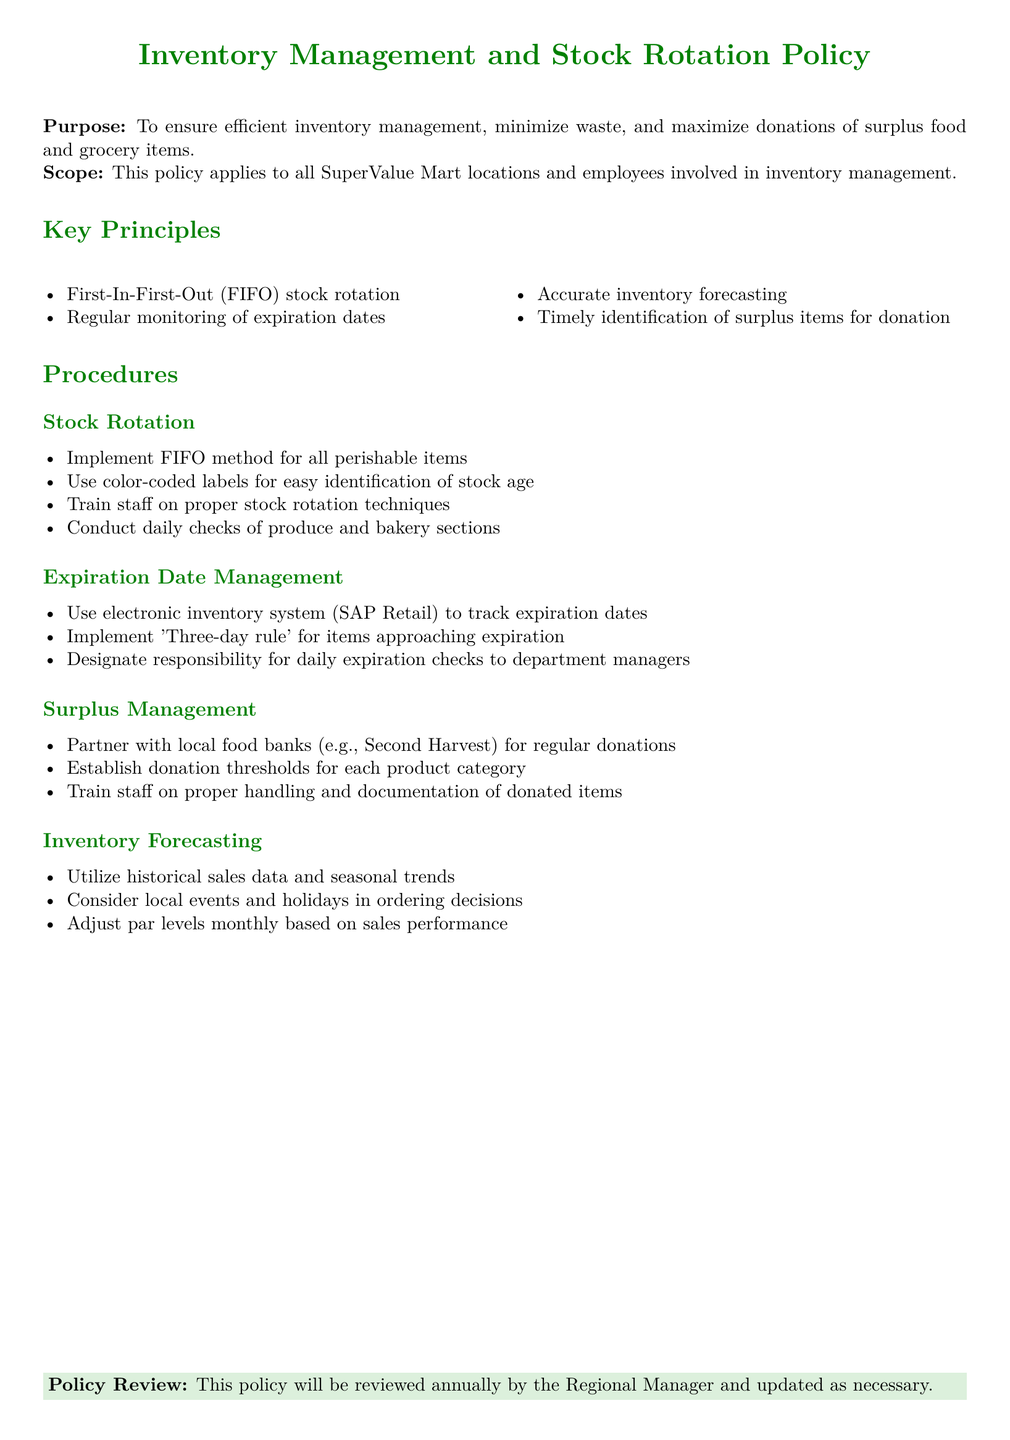What is the purpose of the policy? The purpose of the policy is to ensure efficient inventory management, minimize waste, and maximize donations of surplus food and grocery items.
Answer: To ensure efficient inventory management, minimize waste, and maximize donations of surplus food and grocery items Which method should be implemented for stock rotation? The document specifies the stock rotation method that should be used for perishable items.
Answer: First-In-First-Out (FIFO) What system is used to track expiration dates? The electronic inventory system mentioned in the document is used for tracking expiration dates.
Answer: SAP Retail What is the donation partner mentioned in the policy? The document mentions a specific organization that the supermarket chain partners with for donations.
Answer: Second Harvest What is the 'three-day rule'? The document outlines a rule related to items that are nearing their expiration date.
Answer: Items approaching expiration How often will the policy be reviewed? The document states the frequency of reviews for the policy.
Answer: Annually What is designated for daily expiration checks? The document names the role responsible for conducting daily expiration checks.
Answer: Department managers What should be considered in ordering decisions? The document lists a factor that must be taken into account for inventory ordering.
Answer: Local events and holidays 